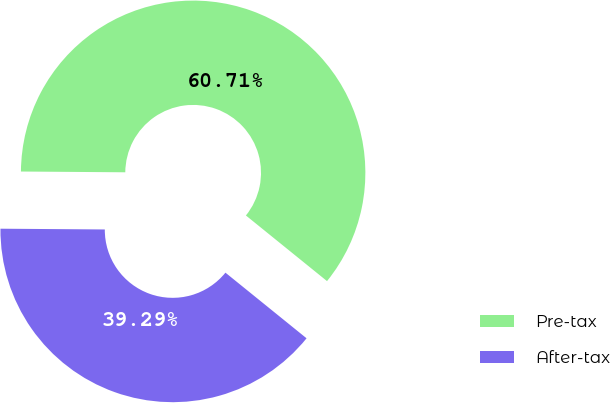Convert chart to OTSL. <chart><loc_0><loc_0><loc_500><loc_500><pie_chart><fcel>Pre-tax<fcel>After-tax<nl><fcel>60.71%<fcel>39.29%<nl></chart> 